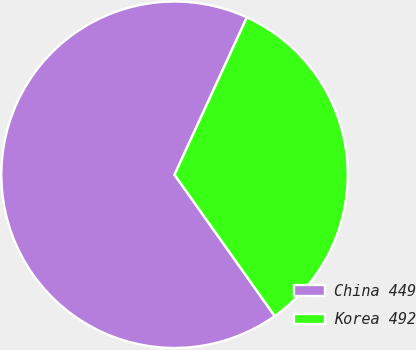Convert chart to OTSL. <chart><loc_0><loc_0><loc_500><loc_500><pie_chart><fcel>China 449<fcel>Korea 492<nl><fcel>66.67%<fcel>33.33%<nl></chart> 